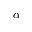<formula> <loc_0><loc_0><loc_500><loc_500>\alpha</formula> 